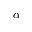<formula> <loc_0><loc_0><loc_500><loc_500>\alpha</formula> 